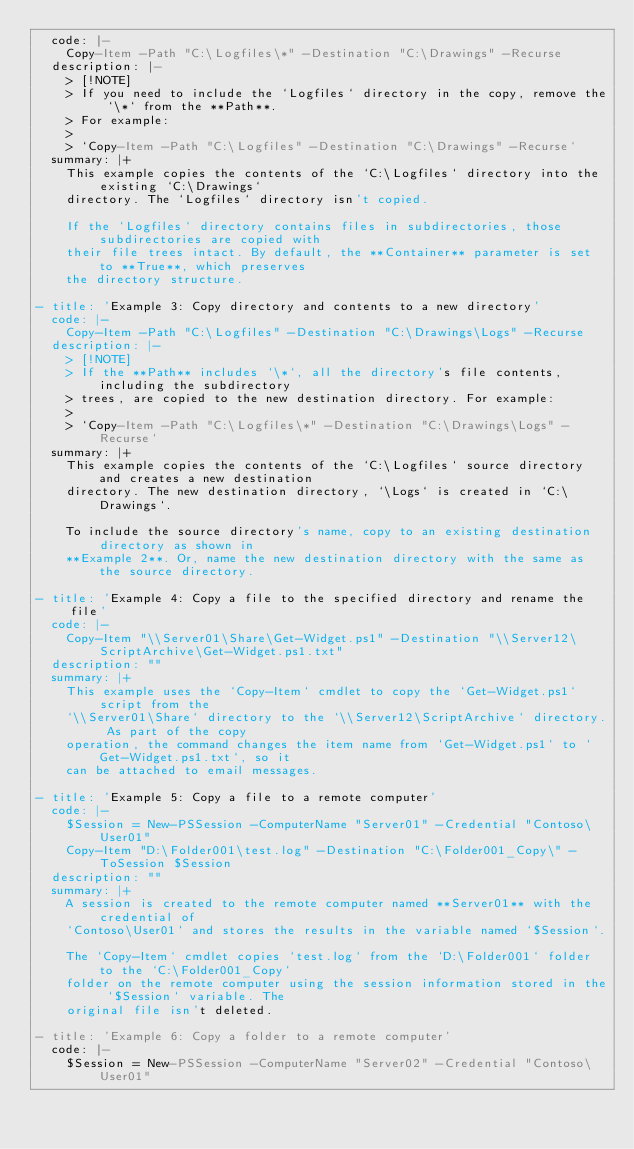Convert code to text. <code><loc_0><loc_0><loc_500><loc_500><_YAML_>  code: |-
    Copy-Item -Path "C:\Logfiles\*" -Destination "C:\Drawings" -Recurse
  description: |-
    > [!NOTE]
    > If you need to include the `Logfiles` directory in the copy, remove the `\*` from the **Path**.
    > For example:
    >
    > `Copy-Item -Path "C:\Logfiles" -Destination "C:\Drawings" -Recurse`
  summary: |+
    This example copies the contents of the `C:\Logfiles` directory into the existing `C:\Drawings`
    directory. The `Logfiles` directory isn't copied.

    If the `Logfiles` directory contains files in subdirectories, those subdirectories are copied with
    their file trees intact. By default, the **Container** parameter is set to **True**, which preserves
    the directory structure.

- title: 'Example 3: Copy directory and contents to a new directory'
  code: |-
    Copy-Item -Path "C:\Logfiles" -Destination "C:\Drawings\Logs" -Recurse
  description: |-
    > [!NOTE]
    > If the **Path** includes `\*`, all the directory's file contents, including the subdirectory
    > trees, are copied to the new destination directory. For example:
    >
    > `Copy-Item -Path "C:\Logfiles\*" -Destination "C:\Drawings\Logs" -Recurse`
  summary: |+
    This example copies the contents of the `C:\Logfiles` source directory and creates a new destination
    directory. The new destination directory, `\Logs` is created in `C:\Drawings`.

    To include the source directory's name, copy to an existing destination directory as shown in
    **Example 2**. Or, name the new destination directory with the same as the source directory.

- title: 'Example 4: Copy a file to the specified directory and rename the file'
  code: |-
    Copy-Item "\\Server01\Share\Get-Widget.ps1" -Destination "\\Server12\ScriptArchive\Get-Widget.ps1.txt"
  description: ""
  summary: |+
    This example uses the `Copy-Item` cmdlet to copy the `Get-Widget.ps1` script from the
    `\\Server01\Share` directory to the `\\Server12\ScriptArchive` directory. As part of the copy
    operation, the command changes the item name from `Get-Widget.ps1` to `Get-Widget.ps1.txt`, so it
    can be attached to email messages.

- title: 'Example 5: Copy a file to a remote computer'
  code: |-
    $Session = New-PSSession -ComputerName "Server01" -Credential "Contoso\User01"
    Copy-Item "D:\Folder001\test.log" -Destination "C:\Folder001_Copy\" -ToSession $Session
  description: ""
  summary: |+
    A session is created to the remote computer named **Server01** with the credential of
    `Contoso\User01` and stores the results in the variable named `$Session`.

    The `Copy-Item` cmdlet copies `test.log` from the `D:\Folder001` folder to the `C:\Folder001_Copy`
    folder on the remote computer using the session information stored in the `$Session` variable. The
    original file isn't deleted.

- title: 'Example 6: Copy a folder to a remote computer'
  code: |-
    $Session = New-PSSession -ComputerName "Server02" -Credential "Contoso\User01"</code> 